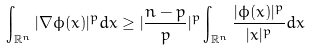Convert formula to latex. <formula><loc_0><loc_0><loc_500><loc_500>\int _ { \mathbb { R } ^ { n } } | \nabla \phi ( x ) | ^ { p } d x \geq | \frac { n - p } { p } | ^ { p } \int _ { \mathbb { R } ^ { n } } \frac { | \phi ( x ) | ^ { p } } { | x | ^ { p } } d x</formula> 